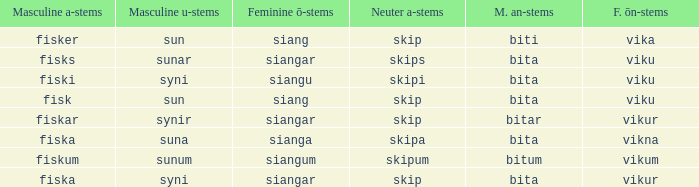What is the masculine u form for the old Swedish word with a neuter a form of skipum? Sunum. 